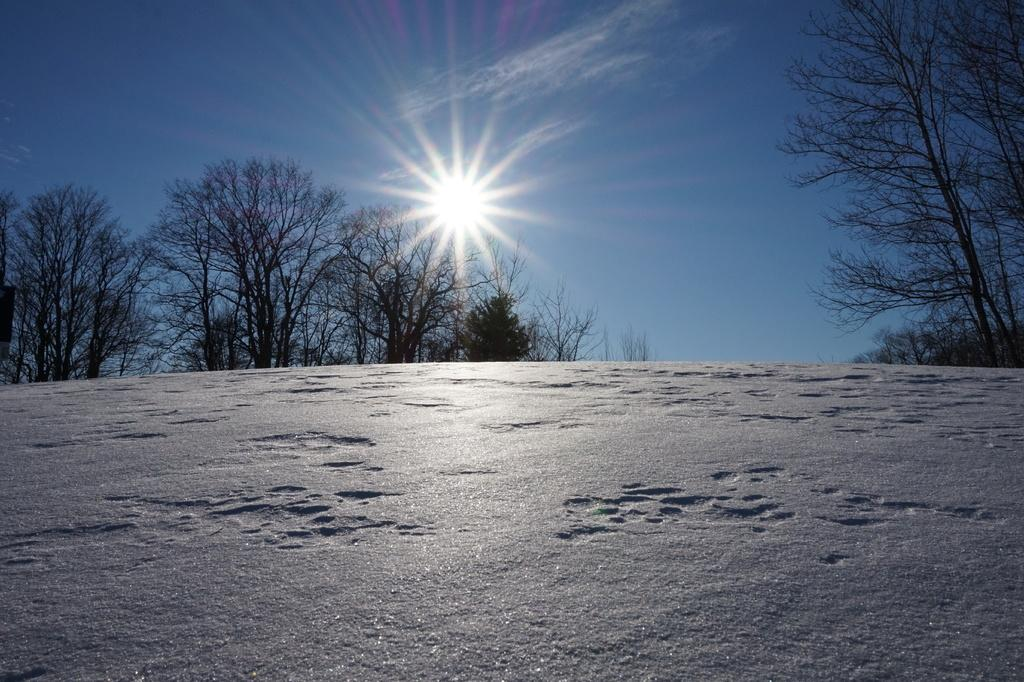What type of setting is depicted in the image? The image is an outside view. What can be seen at the bottom of the image? There is ground visible at the bottom of the image. What is visible in the background of the image? There are trees in the background of the image. What is visible at the top of the image? The sky is visible at the top of the image. Can the sun be seen in the image? Yes, the sun is observable in the sky. How many apples are hanging from the trees in the image? There is no mention of apples in the image, so it is impossible to determine how many apples are hanging from the trees. What type of business is being conducted in the image? There is no indication of any business activity in the image; it is an outside view with trees, sky, and the sun. 